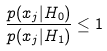Convert formula to latex. <formula><loc_0><loc_0><loc_500><loc_500>\frac { p ( x _ { j } | H _ { 0 } ) } { p ( x _ { j } | H _ { 1 } ) } \leq 1</formula> 